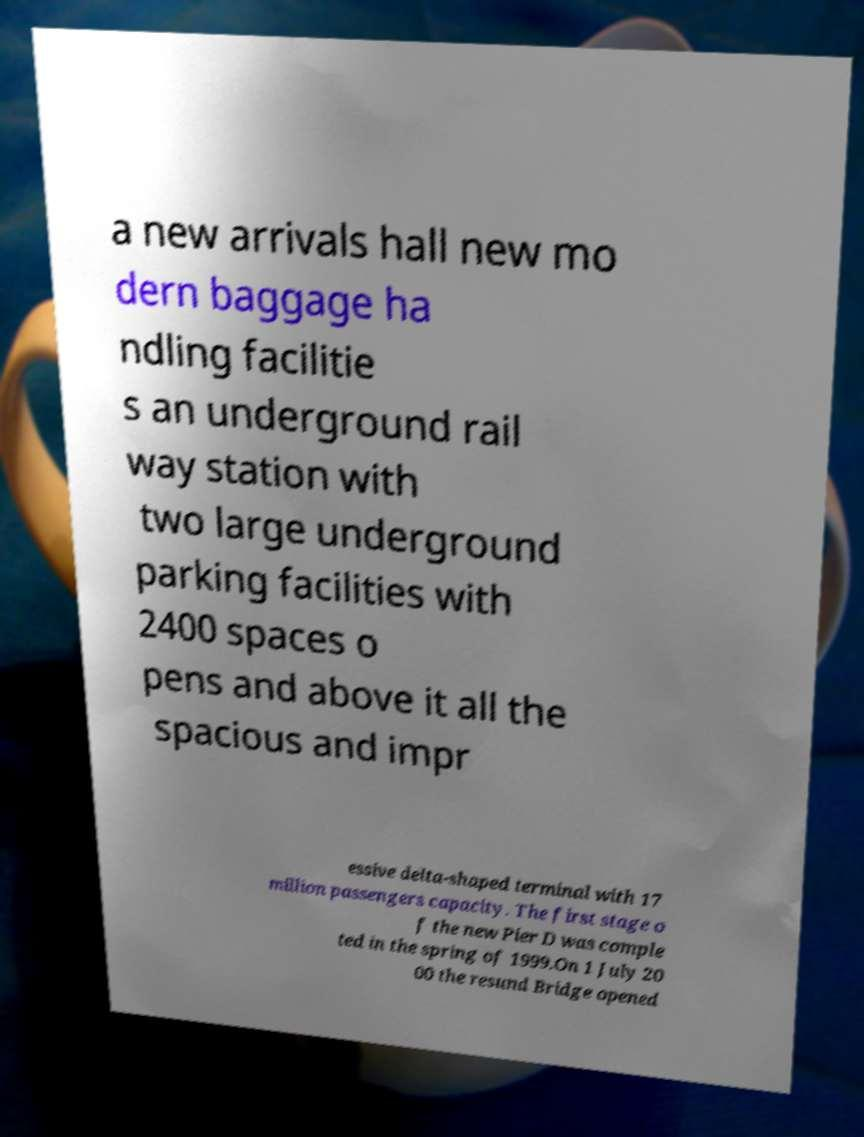What messages or text are displayed in this image? I need them in a readable, typed format. a new arrivals hall new mo dern baggage ha ndling facilitie s an underground rail way station with two large underground parking facilities with 2400 spaces o pens and above it all the spacious and impr essive delta-shaped terminal with 17 million passengers capacity. The first stage o f the new Pier D was comple ted in the spring of 1999.On 1 July 20 00 the resund Bridge opened 